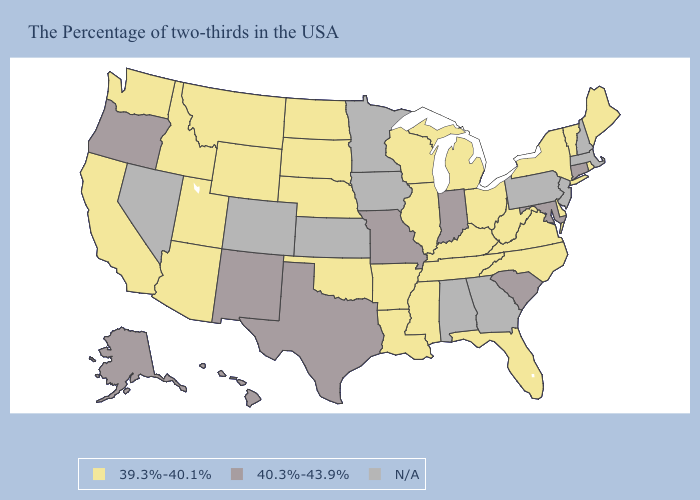What is the value of Kentucky?
Answer briefly. 39.3%-40.1%. What is the lowest value in the Northeast?
Answer briefly. 39.3%-40.1%. Does the map have missing data?
Write a very short answer. Yes. Does the map have missing data?
Short answer required. Yes. Does the map have missing data?
Concise answer only. Yes. Name the states that have a value in the range 39.3%-40.1%?
Quick response, please. Maine, Rhode Island, Vermont, New York, Delaware, Virginia, North Carolina, West Virginia, Ohio, Florida, Michigan, Kentucky, Tennessee, Wisconsin, Illinois, Mississippi, Louisiana, Arkansas, Nebraska, Oklahoma, South Dakota, North Dakota, Wyoming, Utah, Montana, Arizona, Idaho, California, Washington. What is the value of Wyoming?
Short answer required. 39.3%-40.1%. Name the states that have a value in the range N/A?
Give a very brief answer. Massachusetts, New Hampshire, New Jersey, Pennsylvania, Georgia, Alabama, Minnesota, Iowa, Kansas, Colorado, Nevada. What is the value of Kentucky?
Keep it brief. 39.3%-40.1%. Does Connecticut have the lowest value in the Northeast?
Quick response, please. No. Does the first symbol in the legend represent the smallest category?
Be succinct. Yes. Does Connecticut have the lowest value in the Northeast?
Short answer required. No. Which states have the lowest value in the USA?
Quick response, please. Maine, Rhode Island, Vermont, New York, Delaware, Virginia, North Carolina, West Virginia, Ohio, Florida, Michigan, Kentucky, Tennessee, Wisconsin, Illinois, Mississippi, Louisiana, Arkansas, Nebraska, Oklahoma, South Dakota, North Dakota, Wyoming, Utah, Montana, Arizona, Idaho, California, Washington. Does South Dakota have the highest value in the MidWest?
Keep it brief. No. Does the map have missing data?
Keep it brief. Yes. 